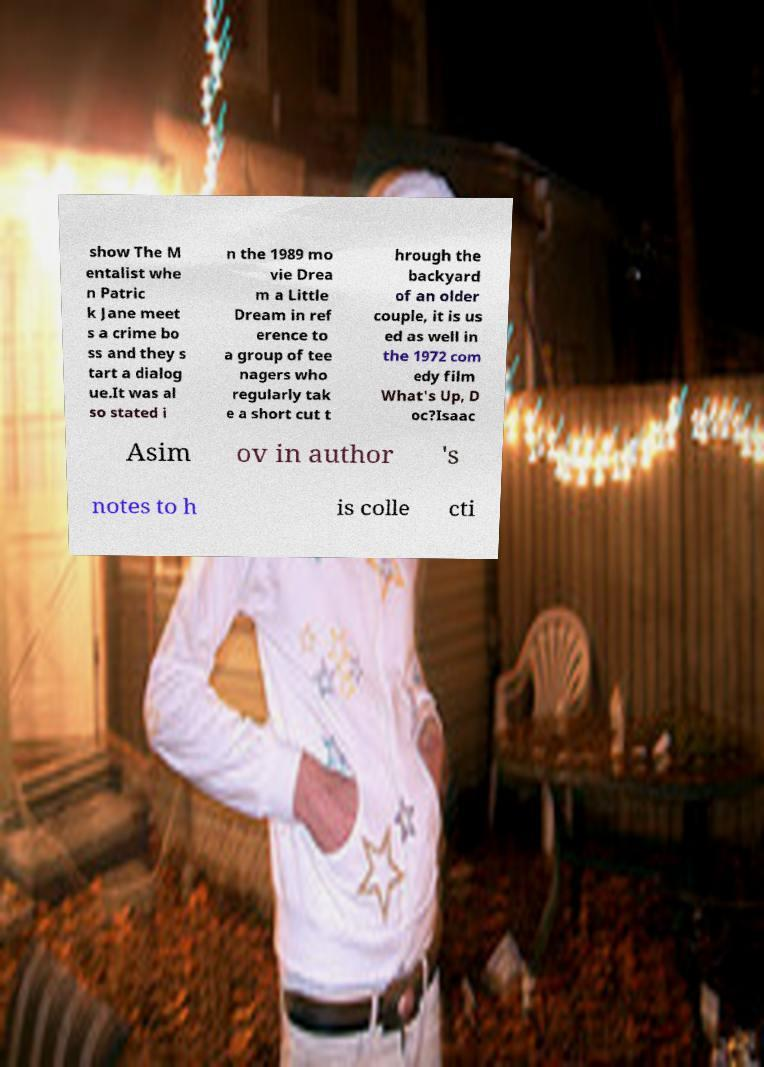I need the written content from this picture converted into text. Can you do that? show The M entalist whe n Patric k Jane meet s a crime bo ss and they s tart a dialog ue.It was al so stated i n the 1989 mo vie Drea m a Little Dream in ref erence to a group of tee nagers who regularly tak e a short cut t hrough the backyard of an older couple, it is us ed as well in the 1972 com edy film What's Up, D oc?Isaac Asim ov in author 's notes to h is colle cti 